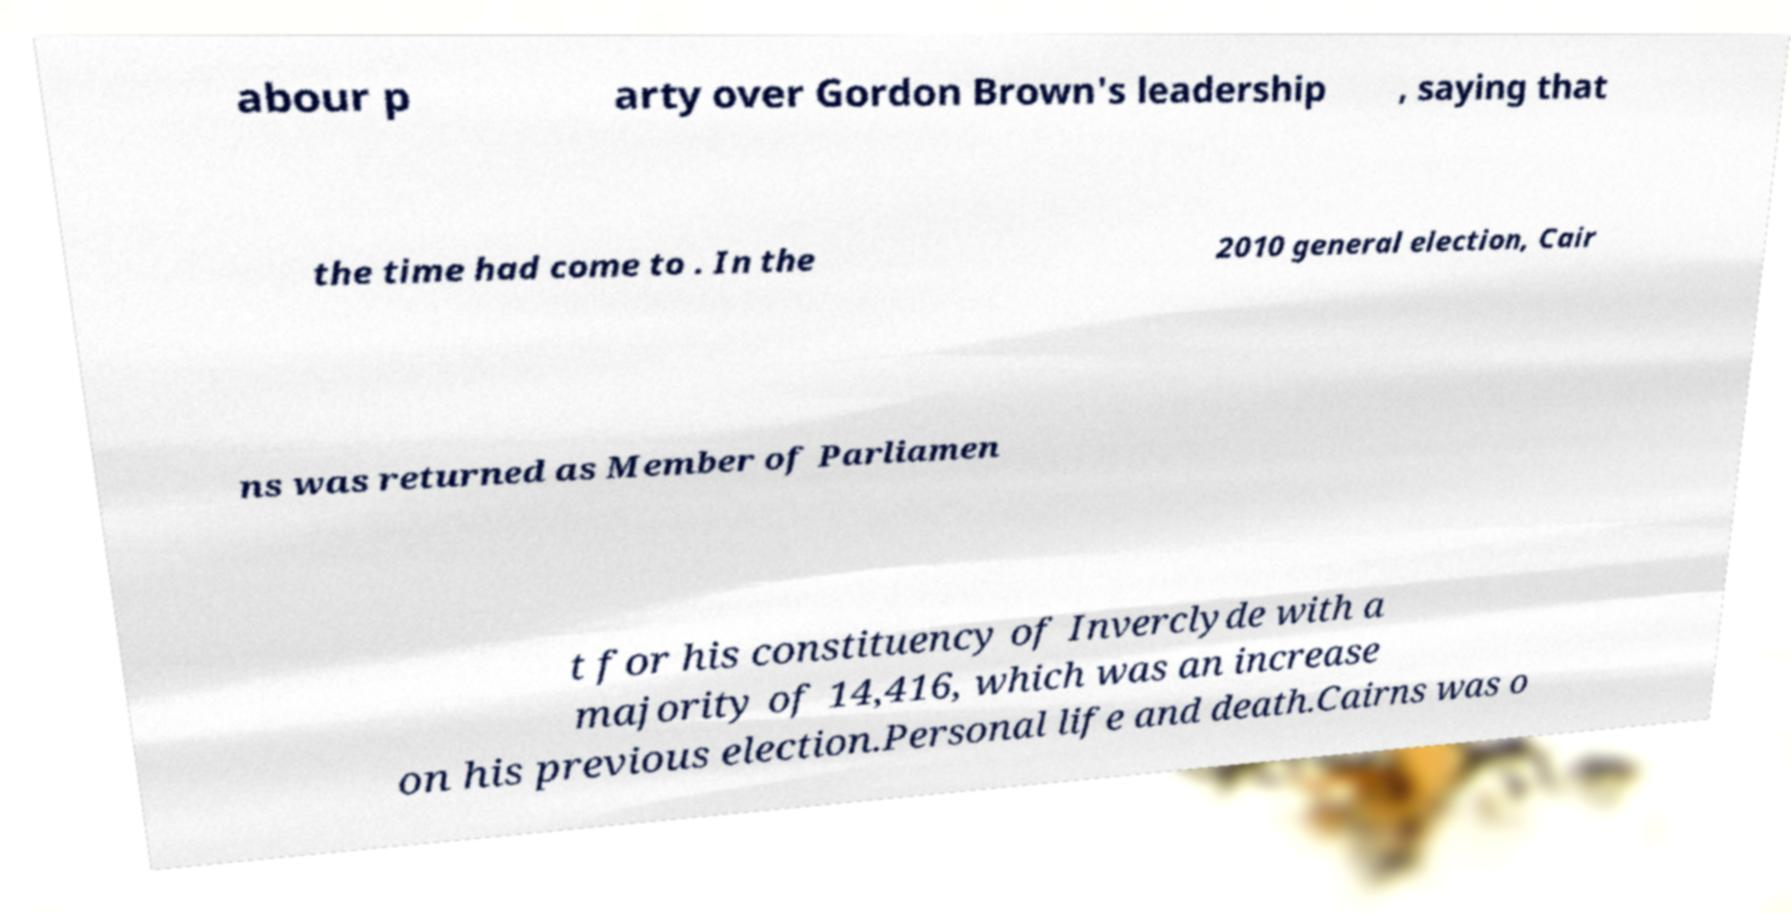Can you read and provide the text displayed in the image?This photo seems to have some interesting text. Can you extract and type it out for me? abour p arty over Gordon Brown's leadership , saying that the time had come to . In the 2010 general election, Cair ns was returned as Member of Parliamen t for his constituency of Inverclyde with a majority of 14,416, which was an increase on his previous election.Personal life and death.Cairns was o 